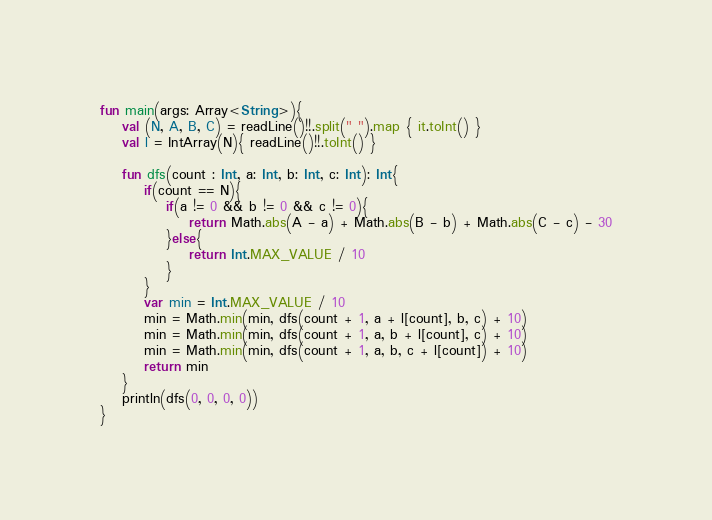<code> <loc_0><loc_0><loc_500><loc_500><_Kotlin_>fun main(args: Array<String>){
    val (N, A, B, C) = readLine()!!.split(" ").map { it.toInt() }
    val l = IntArray(N){ readLine()!!.toInt() }

    fun dfs(count : Int, a: Int, b: Int, c: Int): Int{
        if(count == N){
            if(a != 0 && b != 0 && c != 0){
                return Math.abs(A - a) + Math.abs(B - b) + Math.abs(C - c) - 30
            }else{
                return Int.MAX_VALUE / 10
            }
        }
        var min = Int.MAX_VALUE / 10
        min = Math.min(min, dfs(count + 1, a + l[count], b, c) + 10)
        min = Math.min(min, dfs(count + 1, a, b + l[count], c) + 10)
        min = Math.min(min, dfs(count + 1, a, b, c + l[count]) + 10)
        return min
    }
    println(dfs(0, 0, 0, 0))
}</code> 